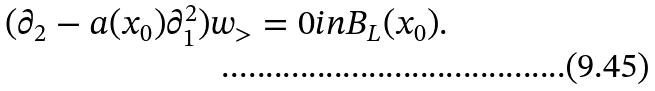Convert formula to latex. <formula><loc_0><loc_0><loc_500><loc_500>( \partial _ { 2 } - a ( x _ { 0 } ) \partial _ { 1 } ^ { 2 } ) w _ { > } = 0 i n B _ { L } ( x _ { 0 } ) .</formula> 